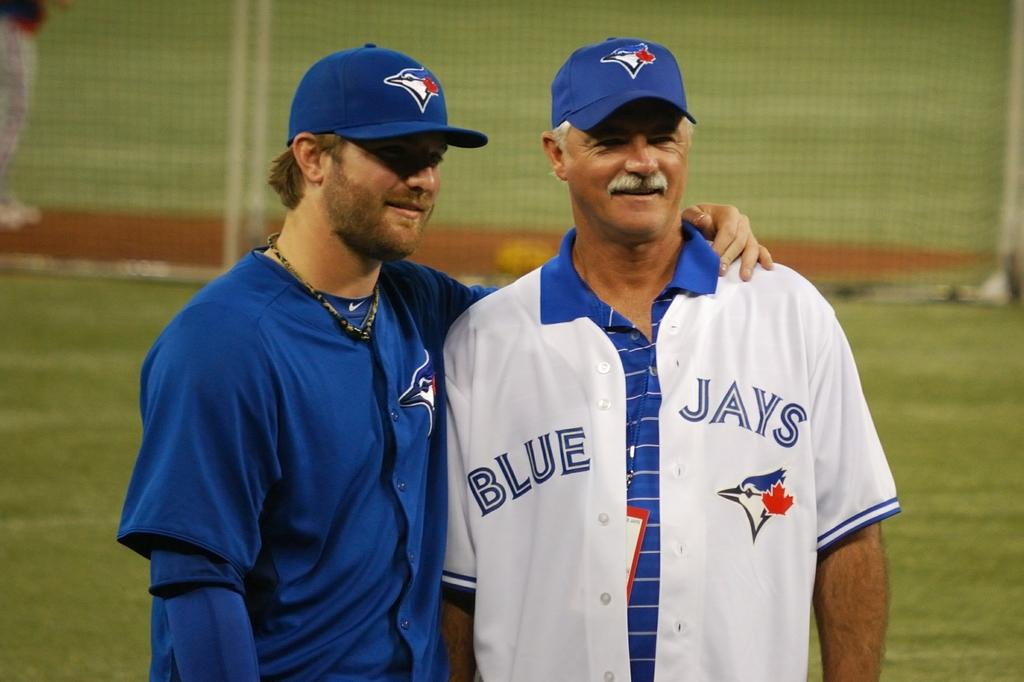Provide a one-sentence caption for the provided image. Two men wearing Blue Jays uniforms on a baseball field. 